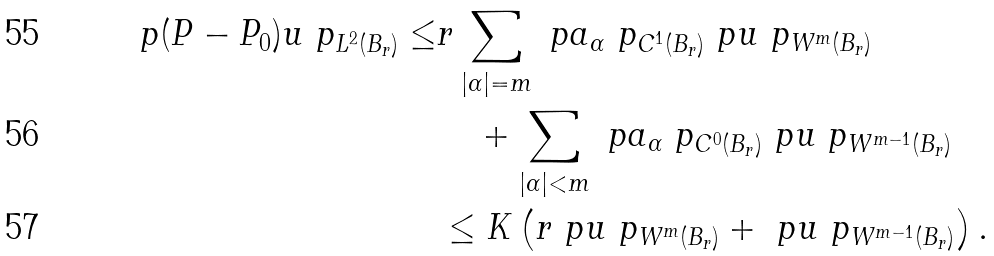<formula> <loc_0><loc_0><loc_500><loc_500>\ p ( P - P _ { 0 } ) u \ p _ { L ^ { 2 } ( B _ { r } ) } \leq & r \sum _ { | \alpha | = m } \ p a _ { \alpha } \ p _ { C ^ { 1 } ( B _ { r } ) } \ p u \ p _ { W ^ { m } ( B _ { r } ) } \\ & \quad + \sum _ { | \alpha | < m } \ p a _ { \alpha } \ p _ { C ^ { 0 } ( B _ { r } ) } \ p u \ p _ { W ^ { m - 1 } ( B _ { r } ) } \\ & \leq K \left ( r \ p u \ p _ { W ^ { m } ( B _ { r } ) } + \ p u \ p _ { W ^ { m - 1 } ( B _ { r } ) } \right ) .</formula> 